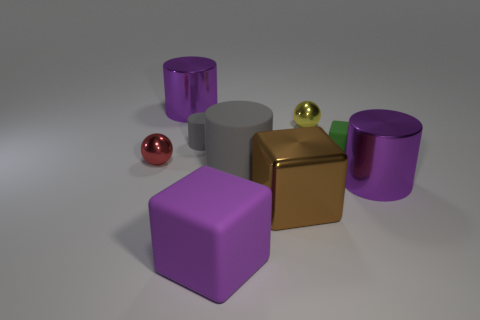What size is the other cylinder that is the same color as the tiny cylinder?
Provide a succinct answer. Large. What number of other objects have the same material as the green thing?
Keep it short and to the point. 3. What number of metal objects are either balls or purple objects?
Give a very brief answer. 4. Do the metal thing that is right of the yellow metallic object and the purple thing that is behind the large gray cylinder have the same shape?
Provide a short and direct response. Yes. The shiny thing that is behind the tiny red shiny thing and right of the tiny gray thing is what color?
Make the answer very short. Yellow. There is a green rubber block that is behind the brown cube; is it the same size as the purple shiny thing that is to the right of the big purple block?
Keep it short and to the point. No. How many tiny objects are the same color as the big shiny cube?
Your response must be concise. 0. What number of large objects are either red metal things or purple matte cylinders?
Ensure brevity in your answer.  0. Do the small ball right of the purple cube and the small cylinder have the same material?
Give a very brief answer. No. The metal sphere in front of the tiny yellow thing is what color?
Ensure brevity in your answer.  Red. 